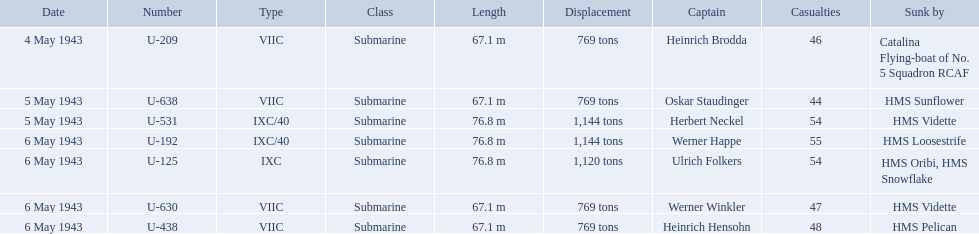What boats were lost on may 5? U-638, U-531. Who were the captains of those boats? Oskar Staudinger, Herbert Neckel. Which captain was not oskar staudinger? Herbert Neckel. Who are the captains of the u boats? Heinrich Brodda, Oskar Staudinger, Herbert Neckel, Werner Happe, Ulrich Folkers, Werner Winkler, Heinrich Hensohn. What are the dates the u boat captains were lost? 4 May 1943, 5 May 1943, 5 May 1943, 6 May 1943, 6 May 1943, 6 May 1943, 6 May 1943. Of these, which were lost on may 5? Oskar Staudinger, Herbert Neckel. Other than oskar staudinger, who else was lost on this day? Herbert Neckel. What is the list of ships under sunk by? Catalina Flying-boat of No. 5 Squadron RCAF, HMS Sunflower, HMS Vidette, HMS Loosestrife, HMS Oribi, HMS Snowflake, HMS Vidette, HMS Pelican. Which captains did hms pelican sink? Heinrich Hensohn. Which were the names of the sinkers of the convoys? Catalina Flying-boat of No. 5 Squadron RCAF, HMS Sunflower, HMS Vidette, HMS Loosestrife, HMS Oribi, HMS Snowflake, HMS Vidette, HMS Pelican. What captain was sunk by the hms pelican? Heinrich Hensohn. 